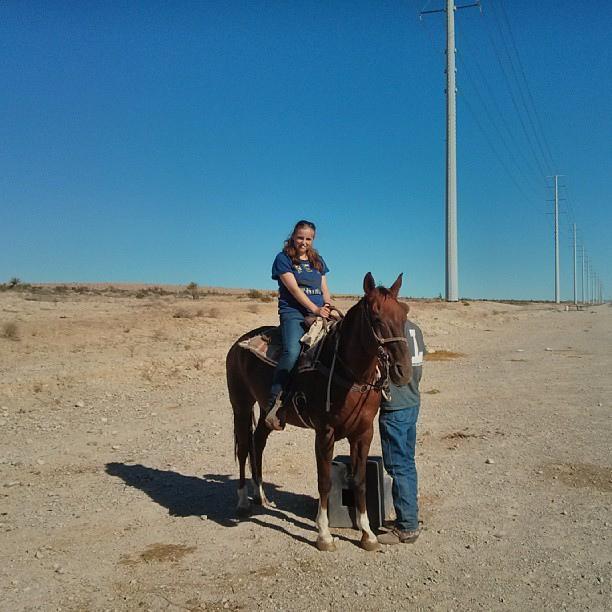If you want to use this transport what can you feed it?
Choose the right answer and clarify with the format: 'Answer: answer
Rationale: rationale.'
Options: Electricity, carrots, coal, gas. Answer: carrots.
Rationale: Carrots are the only food item on the list. 